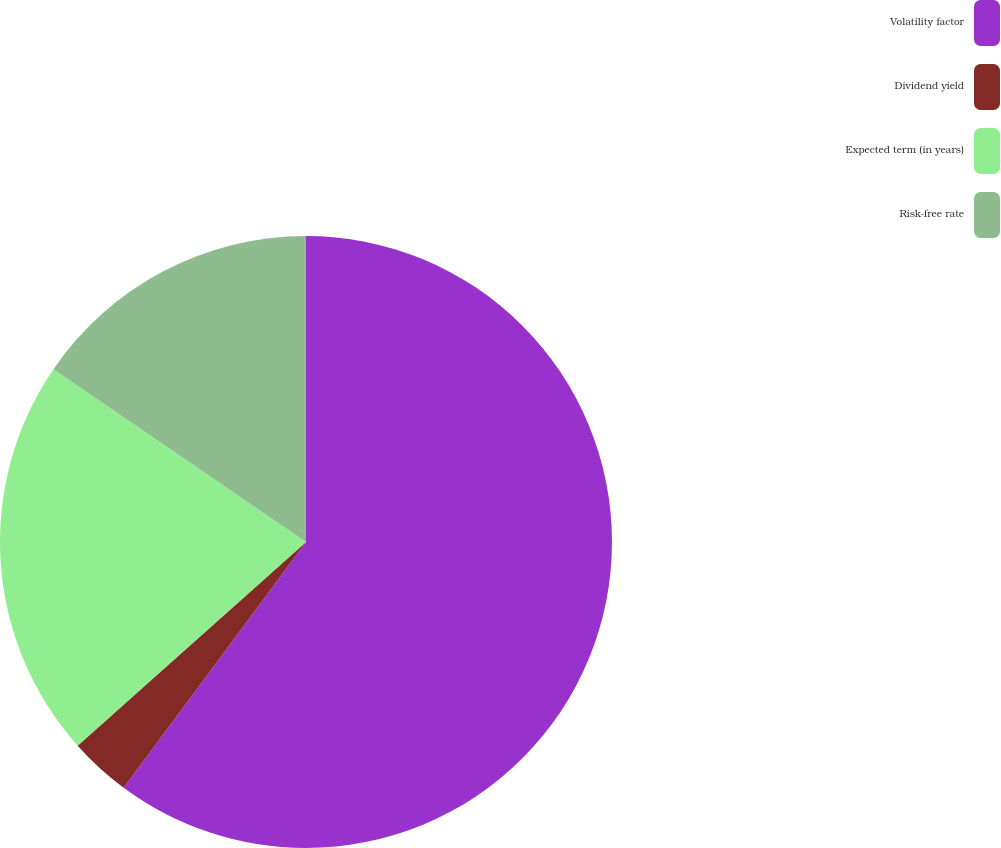Convert chart. <chart><loc_0><loc_0><loc_500><loc_500><pie_chart><fcel>Volatility factor<fcel>Dividend yield<fcel>Expected term (in years)<fcel>Risk-free rate<nl><fcel>60.16%<fcel>3.25%<fcel>21.14%<fcel>15.45%<nl></chart> 